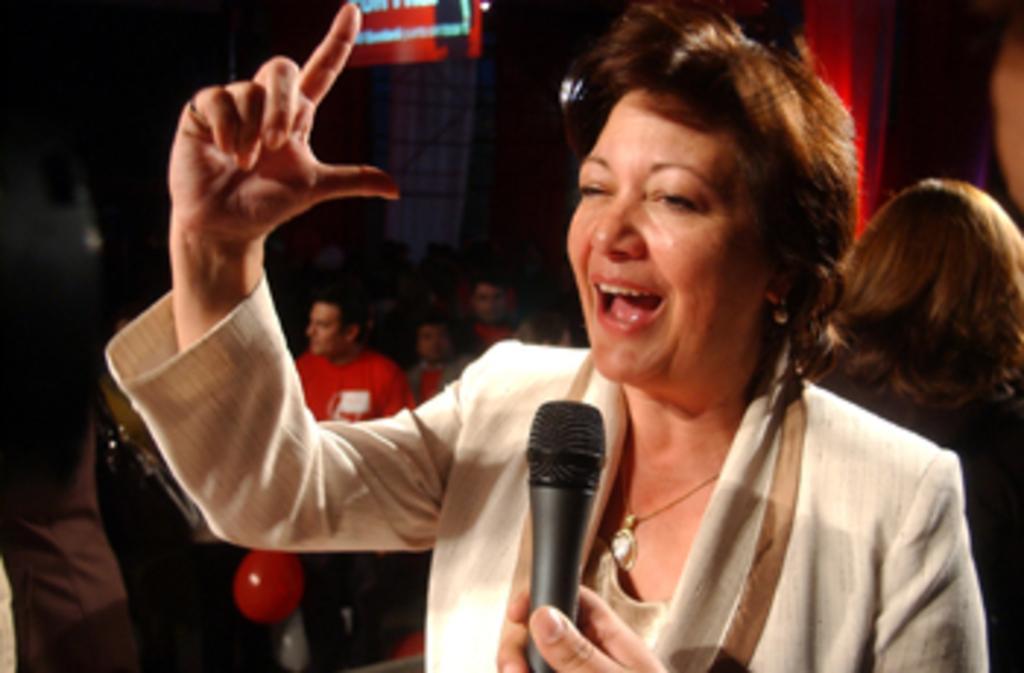Could you give a brief overview of what you see in this image? In this picture there is a woman holding a mic. There are few people at at the background. 